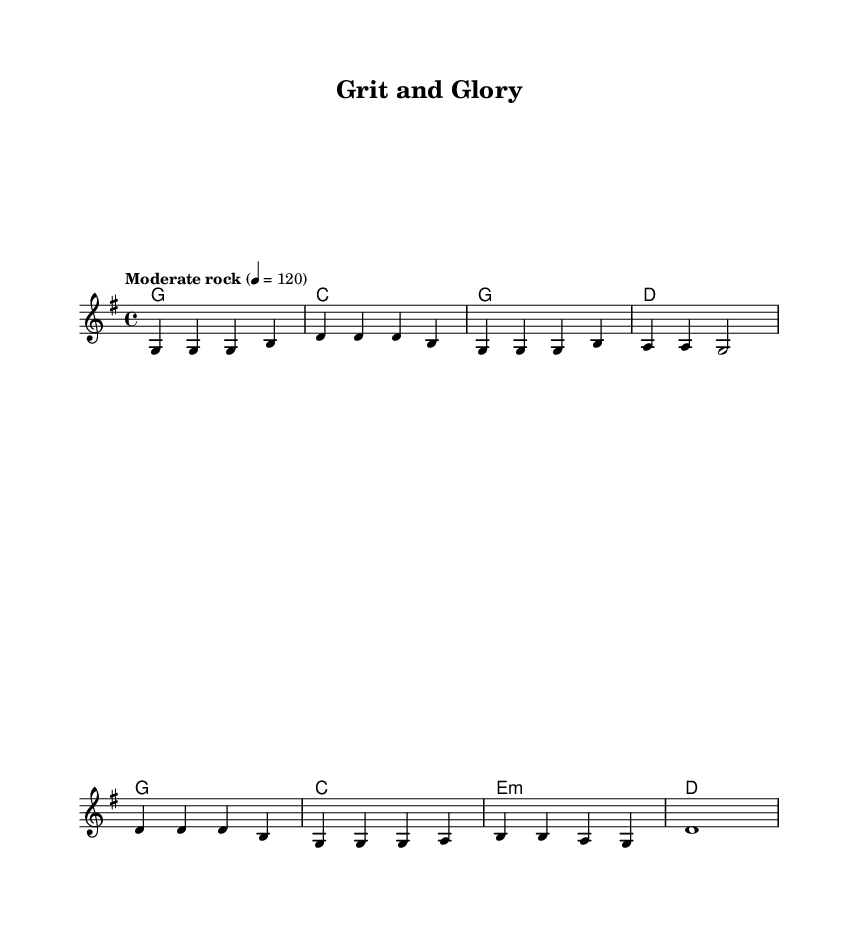What is the key signature of this music? The key signature is G major, which has one sharp (F#). This can be determined by looking at the global section of the LilyPond code, which states '\key g \major'.
Answer: G major What is the time signature of this music? The time signature is 4/4, which is indicated in the global section of the code with '\time 4/4'. This means there are four beats per measure.
Answer: 4/4 What is the tempo marking of this music? The tempo marking is "Moderate rock" at a speed of 120 beats per minute, found in the global section of the code where it states '\tempo "Moderate rock" 4 = 120'.
Answer: Moderate rock 4 = 120 How many measures are in the verse section? The verse section consists of four measures, as noted by the melody markings and the structure of the notes in the code. Counting the lines indicates four distinct sequences.
Answer: 4 What type of chords are primarily used in this song? The primary chords used in the song are major chords, as seen in the harmonies section of the code where it lists G, C, D, and E minor. Major chords often complement the themes in country rock music.
Answer: Major chords What theme does this song convey based on its title? The theme conveyed by the title "Grit and Glory" suggests overcoming challenges associated with the American Dream, a common motif in country rock anthems. This title reflects perseverance and achievement seen in the genre.
Answer: Overcoming challenges What is the final chord in the chorus? The final chord in the chorus is D major, which is noted in the harmonies section of the score. This concluding chord typically provides resolution and closure in the structure of the song.
Answer: D 